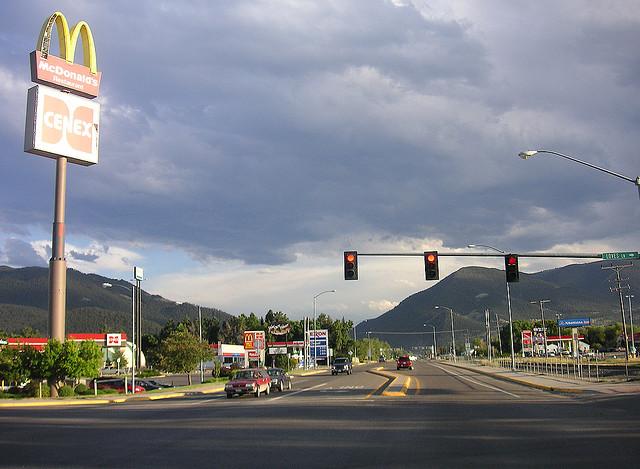Are there many cars on the street?
Answer briefly. No. What fast food company is in the photo?
Write a very short answer. Mcdonald's. Is it raining in the image?
Quick response, please. No. 